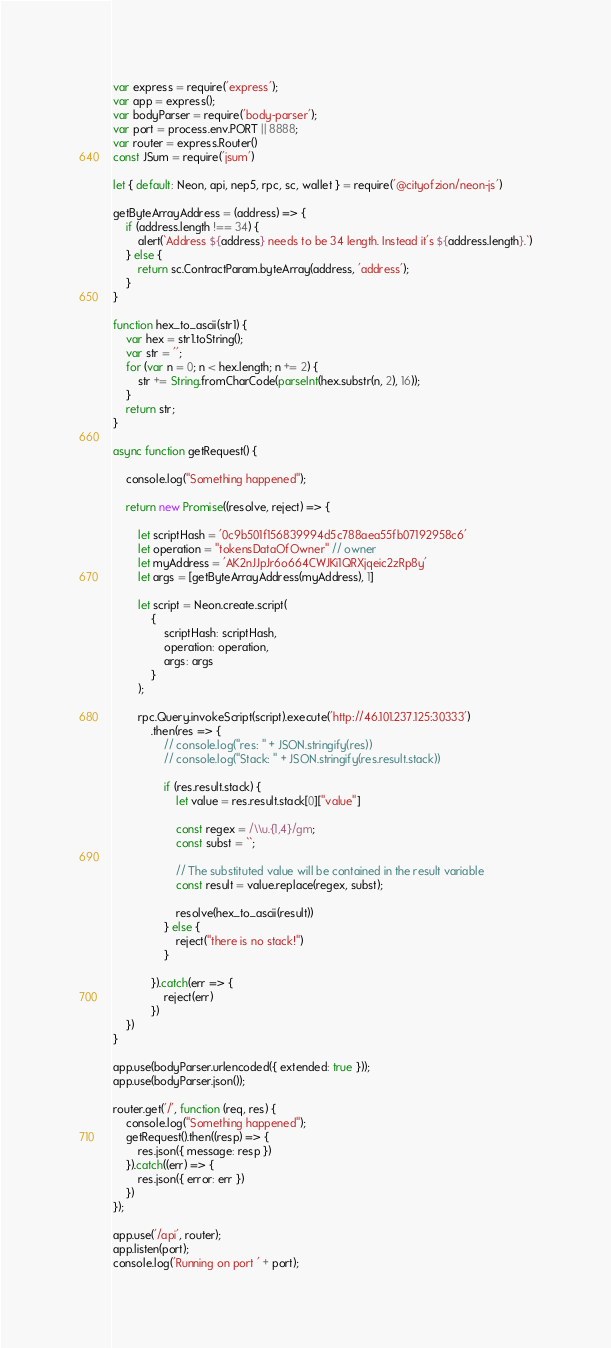Convert code to text. <code><loc_0><loc_0><loc_500><loc_500><_JavaScript_>var express = require('express');
var app = express();
var bodyParser = require('body-parser');
var port = process.env.PORT || 8888;
var router = express.Router()
const JSum = require('jsum')

let { default: Neon, api, nep5, rpc, sc, wallet } = require('@cityofzion/neon-js')

getByteArrayAddress = (address) => {
    if (address.length !== 34) {
        alert(`Address ${address} needs to be 34 length. Instead it's ${address.length}.`)
    } else {
        return sc.ContractParam.byteArray(address, 'address');
    }
}

function hex_to_ascii(str1) {
    var hex = str1.toString();
    var str = '';
    for (var n = 0; n < hex.length; n += 2) {
        str += String.fromCharCode(parseInt(hex.substr(n, 2), 16));
    }
    return str;
}

async function getRequest() {

    console.log("Something happened");

    return new Promise((resolve, reject) => {

        let scriptHash = '0c9b501f156839994d5c788aea55fb07192958c6'
        let operation = "tokensDataOfOwner" // owner
        let myAddress = 'AK2nJJpJr6o664CWJKi1QRXjqeic2zRp8y'
        let args = [getByteArrayAddress(myAddress), 1]

        let script = Neon.create.script(
            {
                scriptHash: scriptHash,
                operation: operation,
                args: args
            }
        );

        rpc.Query.invokeScript(script).execute('http://46.101.237.125:30333')
            .then(res => {
                // console.log("res: " + JSON.stringify(res))
                // console.log("Stack: " + JSON.stringify(res.result.stack))

                if (res.result.stack) {
                    let value = res.result.stack[0]["value"]

                    const regex = /\\u.{1,4}/gm;
                    const subst = ``;

                    // The substituted value will be contained in the result variable
                    const result = value.replace(regex, subst);

                    resolve(hex_to_ascii(result))
                } else {
                    reject("there is no stack!")
                }

            }).catch(err => {
                reject(err)
            })
    })
}

app.use(bodyParser.urlencoded({ extended: true }));
app.use(bodyParser.json());

router.get('/', function (req, res) {
    console.log("Something happened");
    getRequest().then((resp) => {
        res.json({ message: resp })
    }).catch((err) => {
        res.json({ error: err })
    })
});

app.use('/api', router);
app.listen(port);
console.log('Running on port ' + port);
</code> 